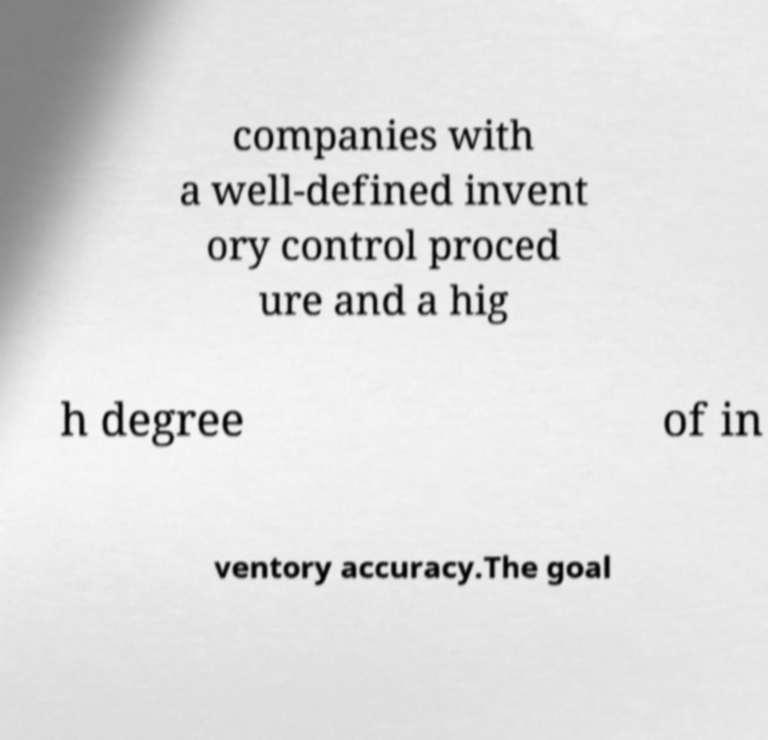For documentation purposes, I need the text within this image transcribed. Could you provide that? companies with a well-defined invent ory control proced ure and a hig h degree of in ventory accuracy.The goal 